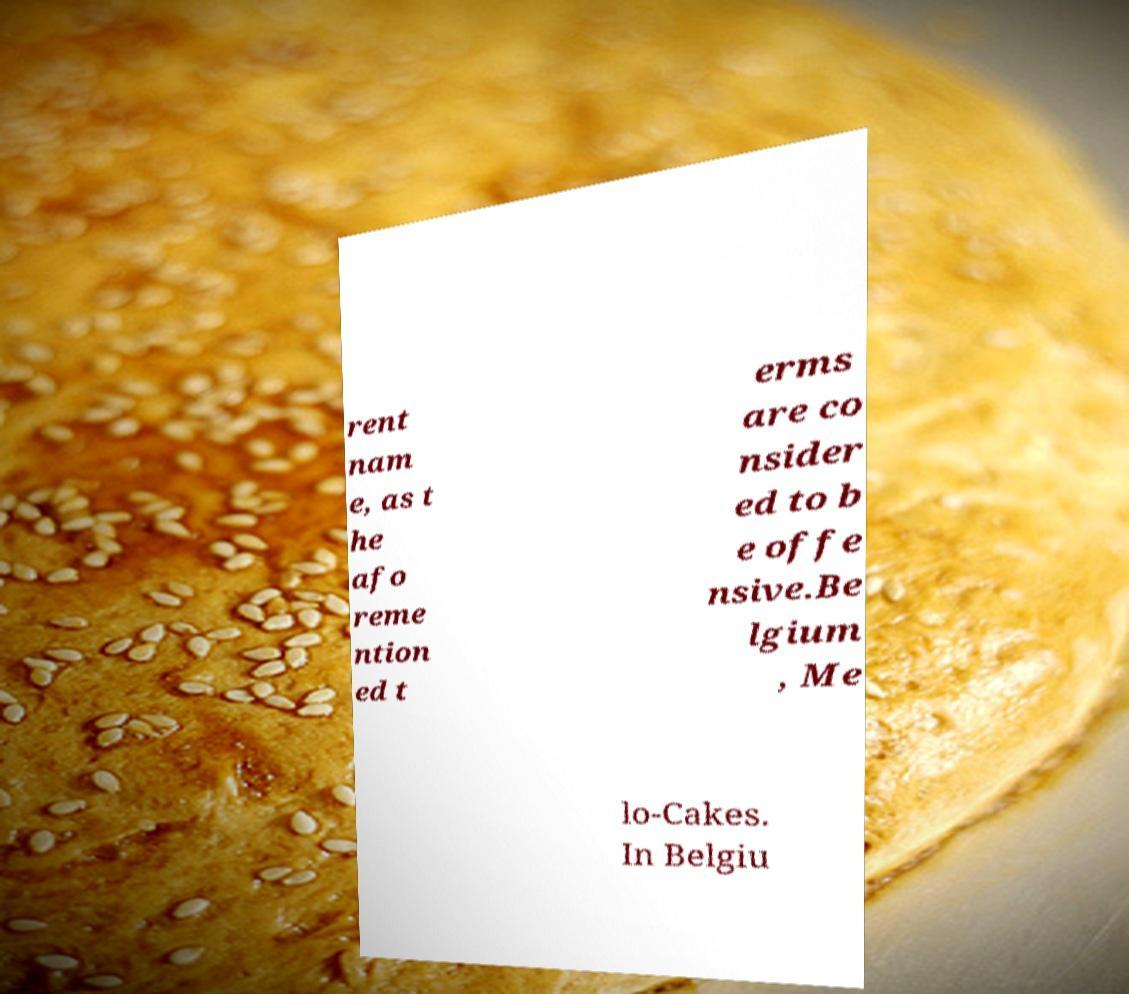I need the written content from this picture converted into text. Can you do that? rent nam e, as t he afo reme ntion ed t erms are co nsider ed to b e offe nsive.Be lgium , Me lo-Cakes. In Belgiu 